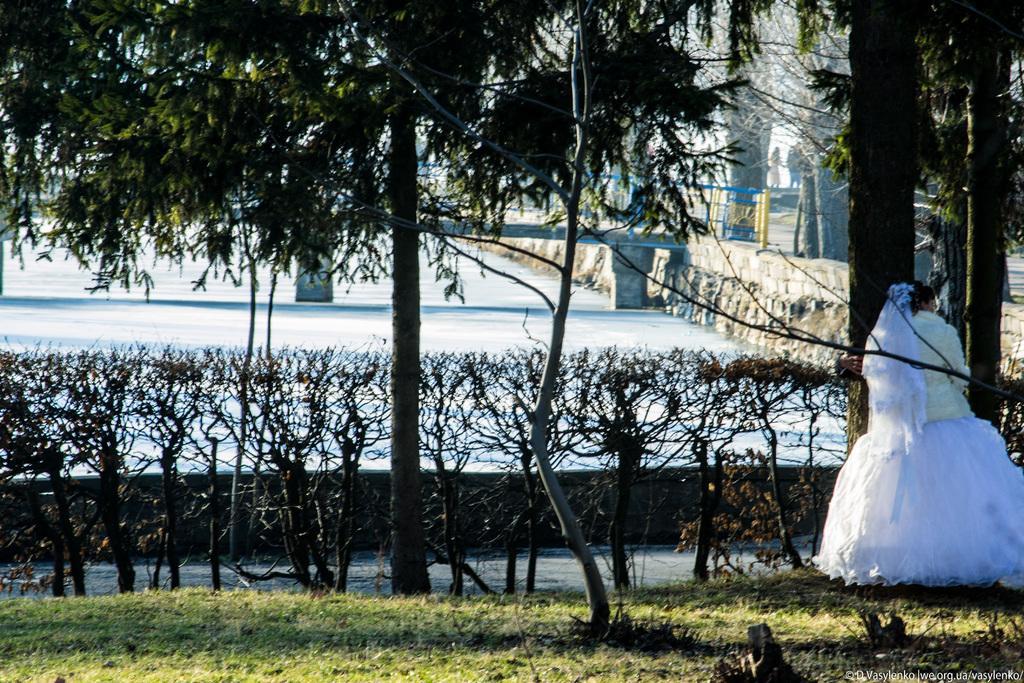Can you describe this image briefly? In this image I can see grass ground and on it I can see number of trees and on the right side I can see one person is standing. I can also see this person is wearing white colour dress. In the background I can see a bridge and few more people. 